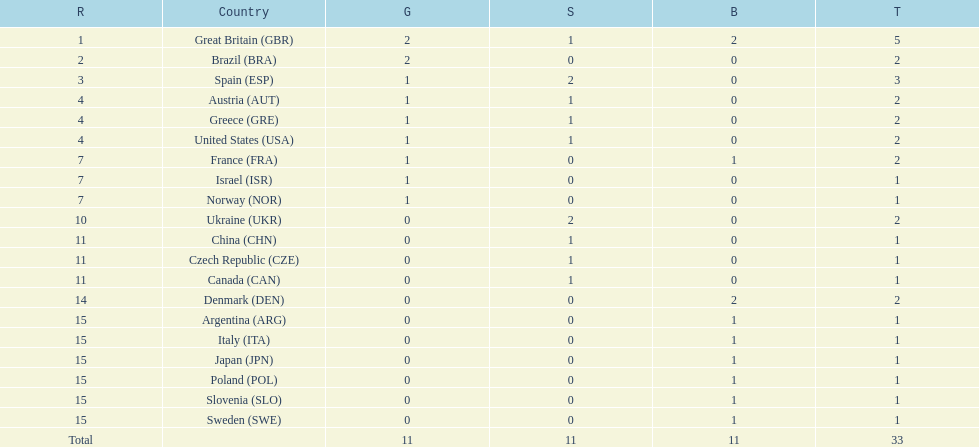What was the number of silver medals won by ukraine? 2. Help me parse the entirety of this table. {'header': ['R', 'Country', 'G', 'S', 'B', 'T'], 'rows': [['1', 'Great Britain\xa0(GBR)', '2', '1', '2', '5'], ['2', 'Brazil\xa0(BRA)', '2', '0', '0', '2'], ['3', 'Spain\xa0(ESP)', '1', '2', '0', '3'], ['4', 'Austria\xa0(AUT)', '1', '1', '0', '2'], ['4', 'Greece\xa0(GRE)', '1', '1', '0', '2'], ['4', 'United States\xa0(USA)', '1', '1', '0', '2'], ['7', 'France\xa0(FRA)', '1', '0', '1', '2'], ['7', 'Israel\xa0(ISR)', '1', '0', '0', '1'], ['7', 'Norway\xa0(NOR)', '1', '0', '0', '1'], ['10', 'Ukraine\xa0(UKR)', '0', '2', '0', '2'], ['11', 'China\xa0(CHN)', '0', '1', '0', '1'], ['11', 'Czech Republic\xa0(CZE)', '0', '1', '0', '1'], ['11', 'Canada\xa0(CAN)', '0', '1', '0', '1'], ['14', 'Denmark\xa0(DEN)', '0', '0', '2', '2'], ['15', 'Argentina\xa0(ARG)', '0', '0', '1', '1'], ['15', 'Italy\xa0(ITA)', '0', '0', '1', '1'], ['15', 'Japan\xa0(JPN)', '0', '0', '1', '1'], ['15', 'Poland\xa0(POL)', '0', '0', '1', '1'], ['15', 'Slovenia\xa0(SLO)', '0', '0', '1', '1'], ['15', 'Sweden\xa0(SWE)', '0', '0', '1', '1'], ['Total', '', '11', '11', '11', '33']]} 